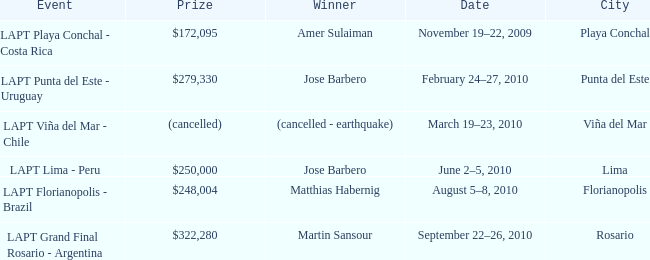Who is the winner in the city of lima? Jose Barbero. 